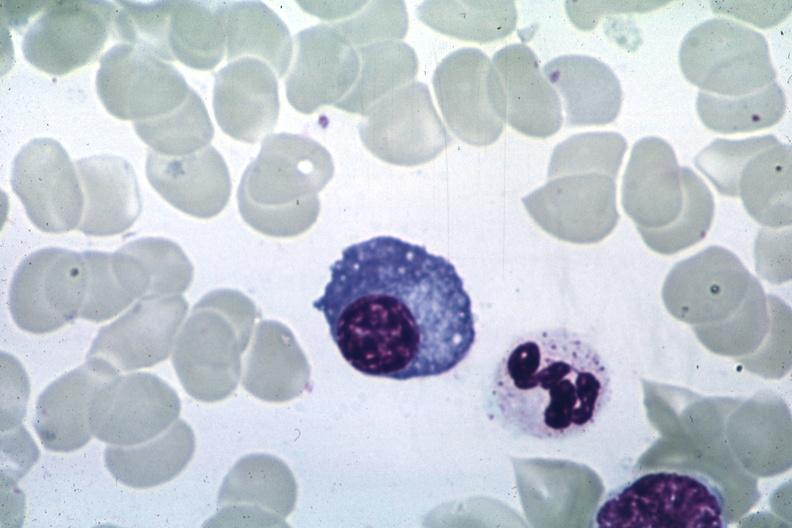s artery present?
Answer the question using a single word or phrase. No 